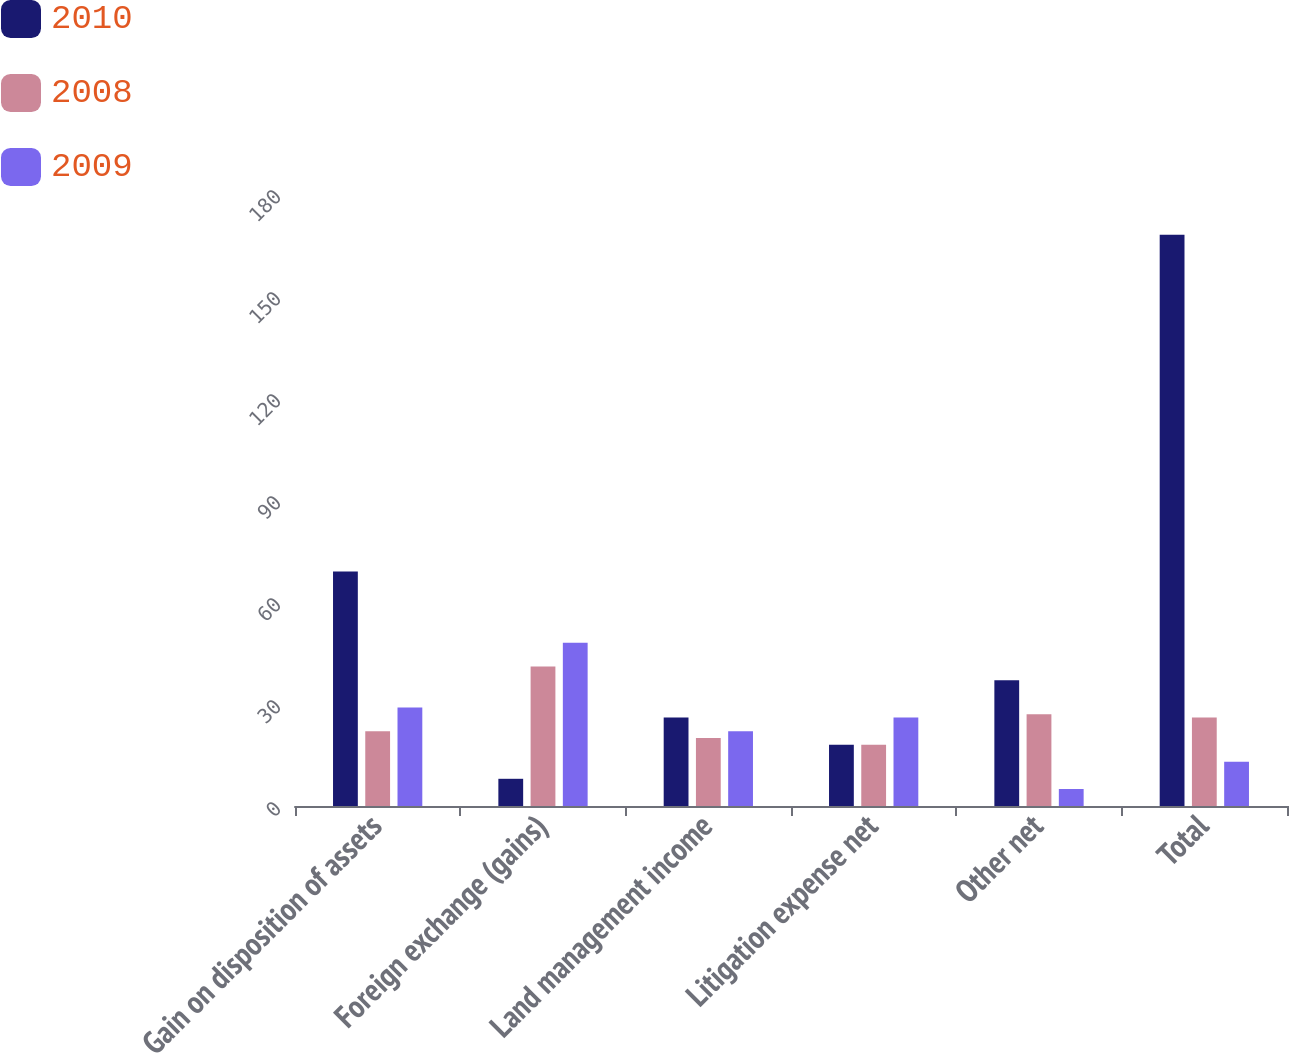Convert chart. <chart><loc_0><loc_0><loc_500><loc_500><stacked_bar_chart><ecel><fcel>Gain on disposition of assets<fcel>Foreign exchange (gains)<fcel>Land management income<fcel>Litigation expense net<fcel>Other net<fcel>Total<nl><fcel>2010<fcel>69<fcel>8<fcel>26<fcel>18<fcel>37<fcel>168<nl><fcel>2008<fcel>22<fcel>41<fcel>20<fcel>18<fcel>27<fcel>26<nl><fcel>2009<fcel>29<fcel>48<fcel>22<fcel>26<fcel>5<fcel>13<nl></chart> 